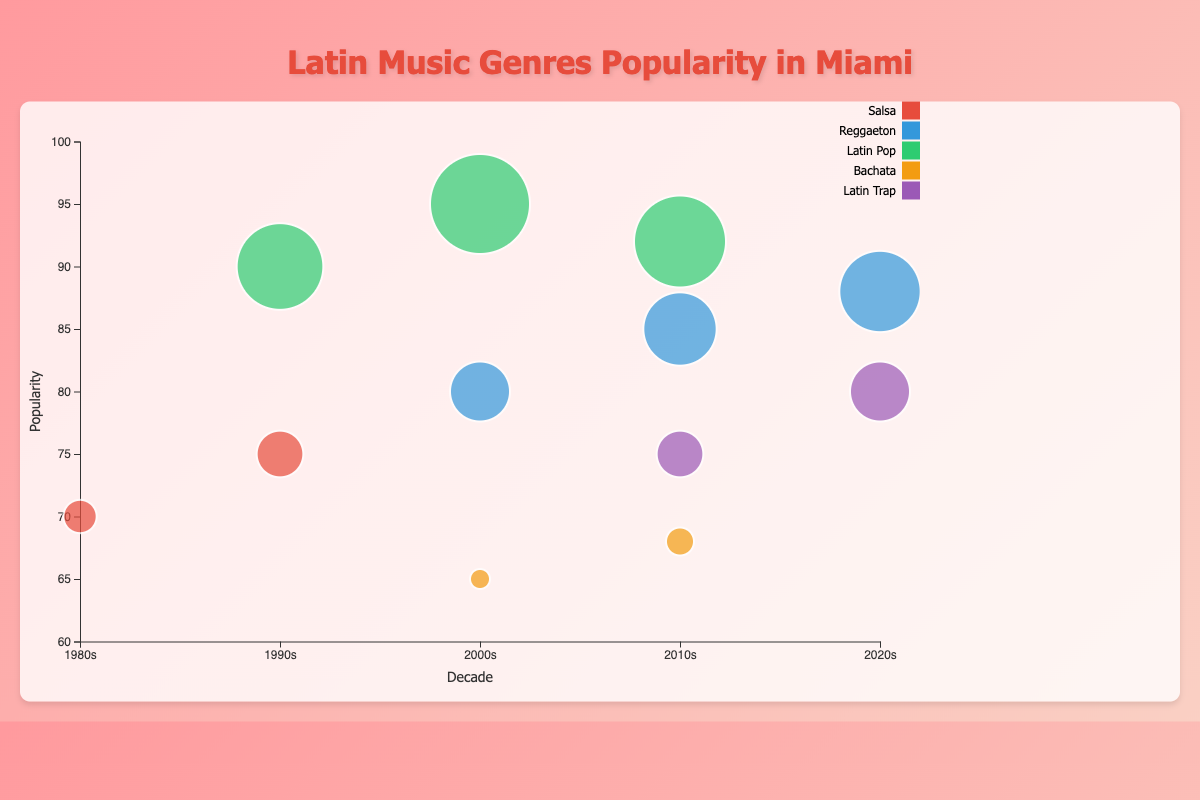What is the most popular Latin music genre in the 2000s? The 2000s have three genres: Reggaeton (80), Latin Pop (95), and Bachata (65). Latin Pop has the highest popularity.
Answer: Latin Pop Which genre has the highest popularity in the 2010s? The genres in the 2010s include Reggaeton (85), Latin Pop (92), Bachata (68), and Latin Trap (75). Latin Pop has the highest popularity.
Answer: Latin Pop How many different genres are represented in the 2020s? Examine the unique genres in the 2020s: Reggaeton and Latin Trap. There are two genres.
Answer: 2 What artist represents the most popular genre in the 1990s? The 1990s have two genres: Salsa (75) with Marc Anthony and Latin Pop (90) with Ricky Martin. Latin Pop is the most popular, represented by Ricky Martin.
Answer: Ricky Martin What is the total popularity of all genres in the 2010s? Sum the popularity values in the 2010s: Reggaeton (85) + Latin Pop (92) + Bachata (68) + Latin Trap (75). The total is 320.
Answer: 320 Which genre has the lowest popularity and in which decade? Evaluate all popularity values; Bachata in the 2000s (65) is the lowest.
Answer: Bachata in the 2000s Compare the popularity of Reggaeton between the 2000s and 2020s. Which decade has higher popularity? Reggaeton's popularity in the 2000s is 80, and in the 2020s it is 88. Therefore, it is higher in the 2020s.
Answer: 2020s Which genre has shown consistent presence across the decades from the 2000s to 2020s? Reggaeton appears consistently in the 2000s, 2010s, and 2020s (80, 85, 88). Other genres do not appear in all three decades.
Answer: Reggaeton What is the average popularity of genres in the 1990s? In the 1990s, Salsa has 75 and Latin Pop 90. The average is (75 + 90) / 2 = 82.5.
Answer: 82.5 